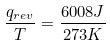<formula> <loc_0><loc_0><loc_500><loc_500>\frac { q _ { r e v } } { T } = \frac { 6 0 0 8 J } { 2 7 3 K }</formula> 